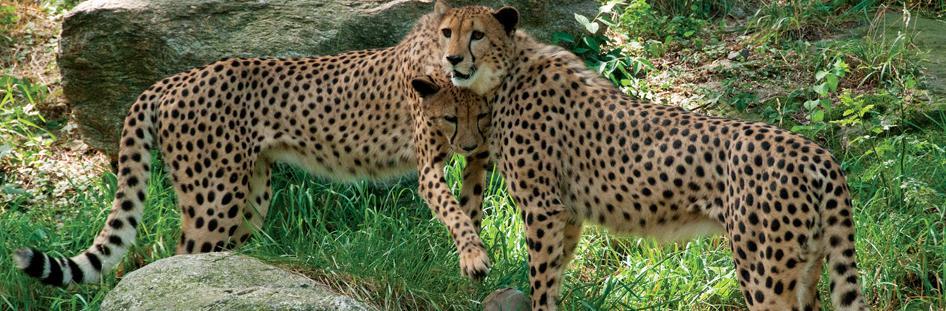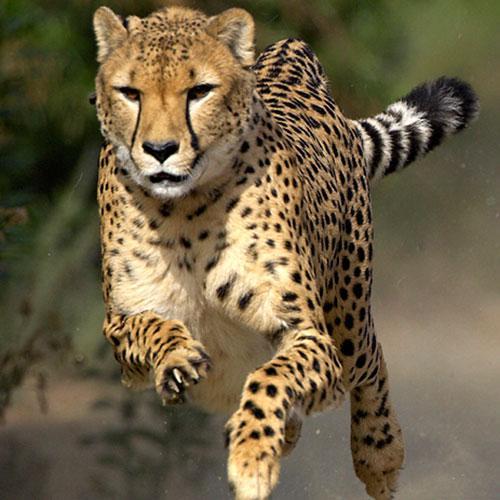The first image is the image on the left, the second image is the image on the right. Assess this claim about the two images: "Exactly three cheetahs are shown, with two in one image sedentary, and the third in the other image running with its front paws off the ground.". Correct or not? Answer yes or no. Yes. The first image is the image on the left, the second image is the image on the right. Assess this claim about the two images: "Several animals are in a grassy are in the image on the left.". Correct or not? Answer yes or no. Yes. 